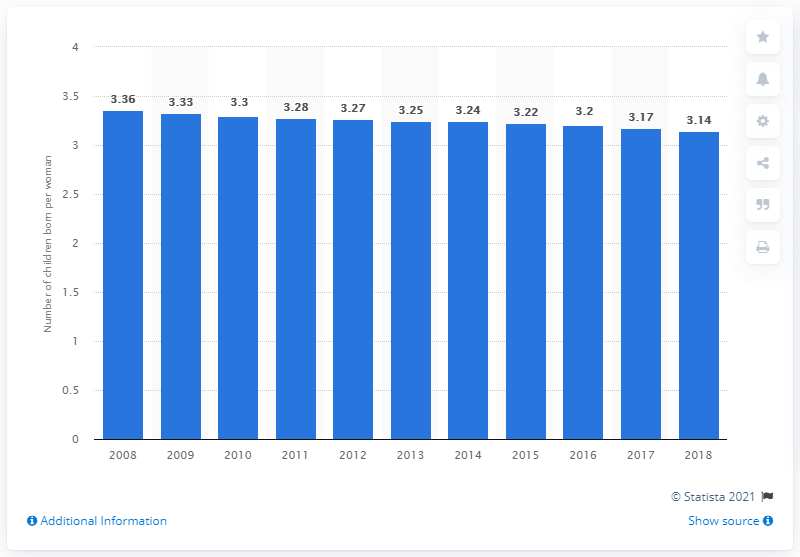Point out several critical features in this image. The fertility rate in Lesotho in 2018 was 3.14. 